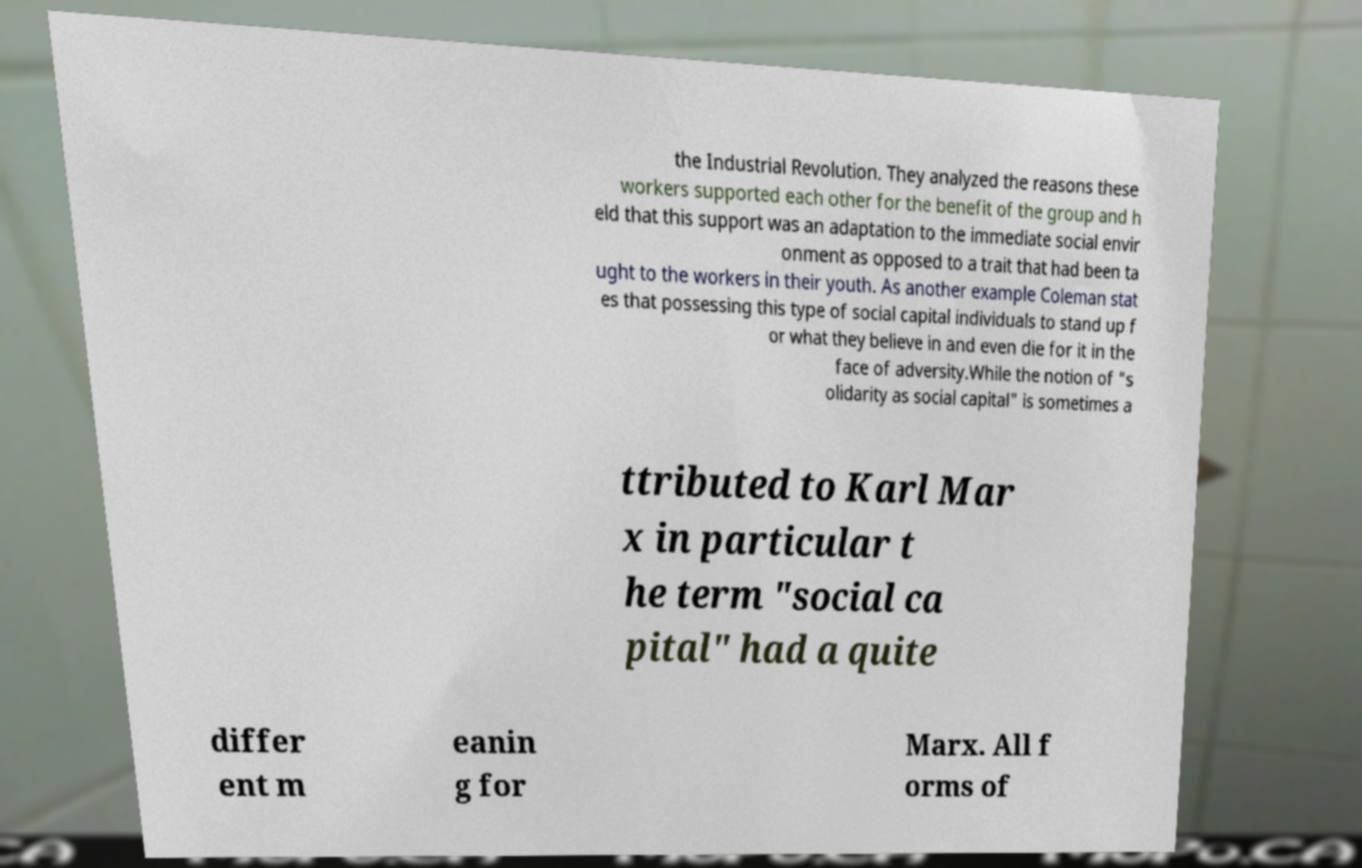There's text embedded in this image that I need extracted. Can you transcribe it verbatim? the Industrial Revolution. They analyzed the reasons these workers supported each other for the benefit of the group and h eld that this support was an adaptation to the immediate social envir onment as opposed to a trait that had been ta ught to the workers in their youth. As another example Coleman stat es that possessing this type of social capital individuals to stand up f or what they believe in and even die for it in the face of adversity.While the notion of "s olidarity as social capital" is sometimes a ttributed to Karl Mar x in particular t he term "social ca pital" had a quite differ ent m eanin g for Marx. All f orms of 